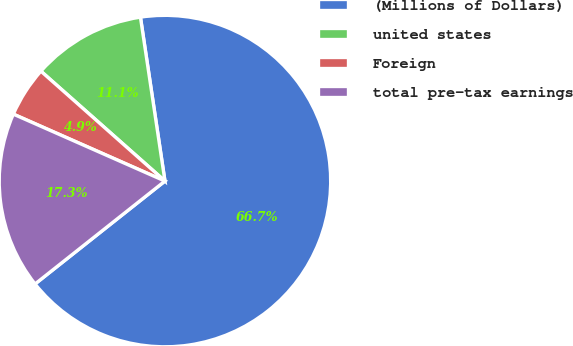Convert chart. <chart><loc_0><loc_0><loc_500><loc_500><pie_chart><fcel>(Millions of Dollars)<fcel>united states<fcel>Foreign<fcel>total pre-tax earnings<nl><fcel>66.7%<fcel>11.1%<fcel>4.92%<fcel>17.28%<nl></chart> 